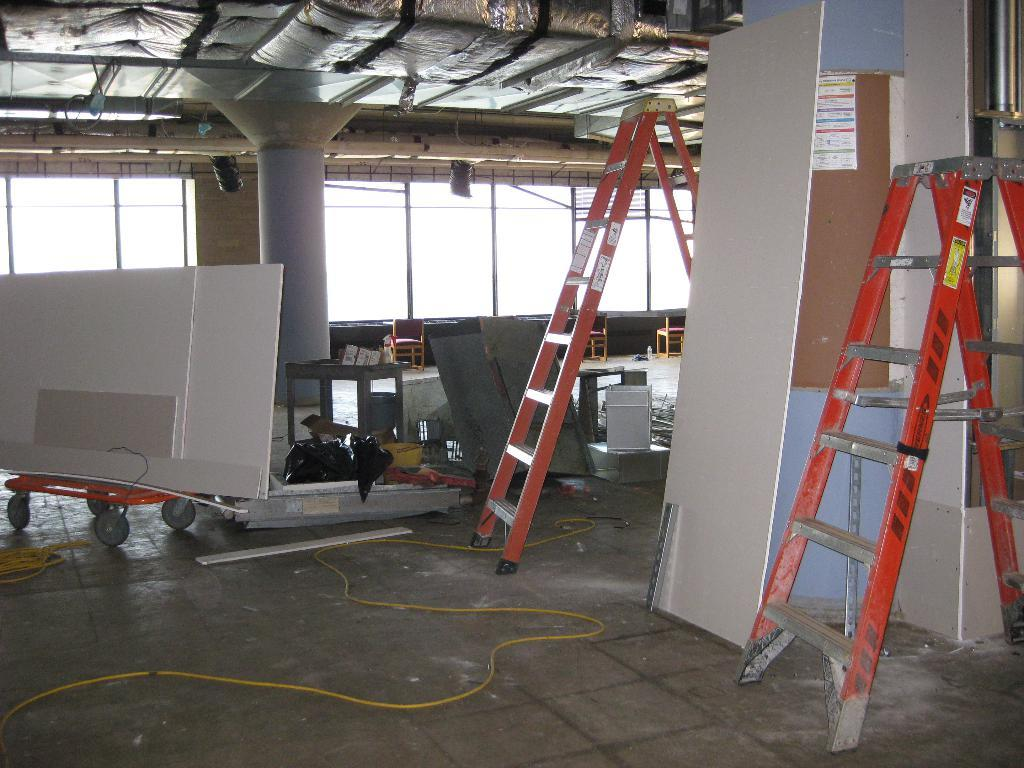What type of equipment can be seen in the image? There are ladders, boards, and a pillar in the image. What is on the floor in the image? There are objects on the floor in the image. What can be seen in the background of the image? There is a framed glass wall, a ceiling, and other objects in the background of the image. What type of class is being held in the image? There is no class or any indication of a class being held in the image. What kind of trouble are the ladders causing in the image? The ladders are not causing any trouble in the image; they are simply equipment that can be seen. 